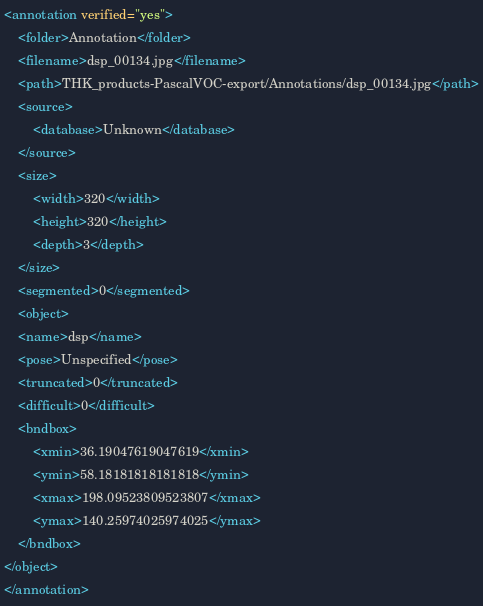<code> <loc_0><loc_0><loc_500><loc_500><_XML_><annotation verified="yes">
    <folder>Annotation</folder>
    <filename>dsp_00134.jpg</filename>
    <path>THK_products-PascalVOC-export/Annotations/dsp_00134.jpg</path>
    <source>
        <database>Unknown</database>
    </source>
    <size>
        <width>320</width>
        <height>320</height>
        <depth>3</depth>
    </size>
    <segmented>0</segmented>
    <object>
    <name>dsp</name>
    <pose>Unspecified</pose>
    <truncated>0</truncated>
    <difficult>0</difficult>
    <bndbox>
        <xmin>36.19047619047619</xmin>
        <ymin>58.18181818181818</ymin>
        <xmax>198.09523809523807</xmax>
        <ymax>140.25974025974025</ymax>
    </bndbox>
</object>
</annotation>
</code> 